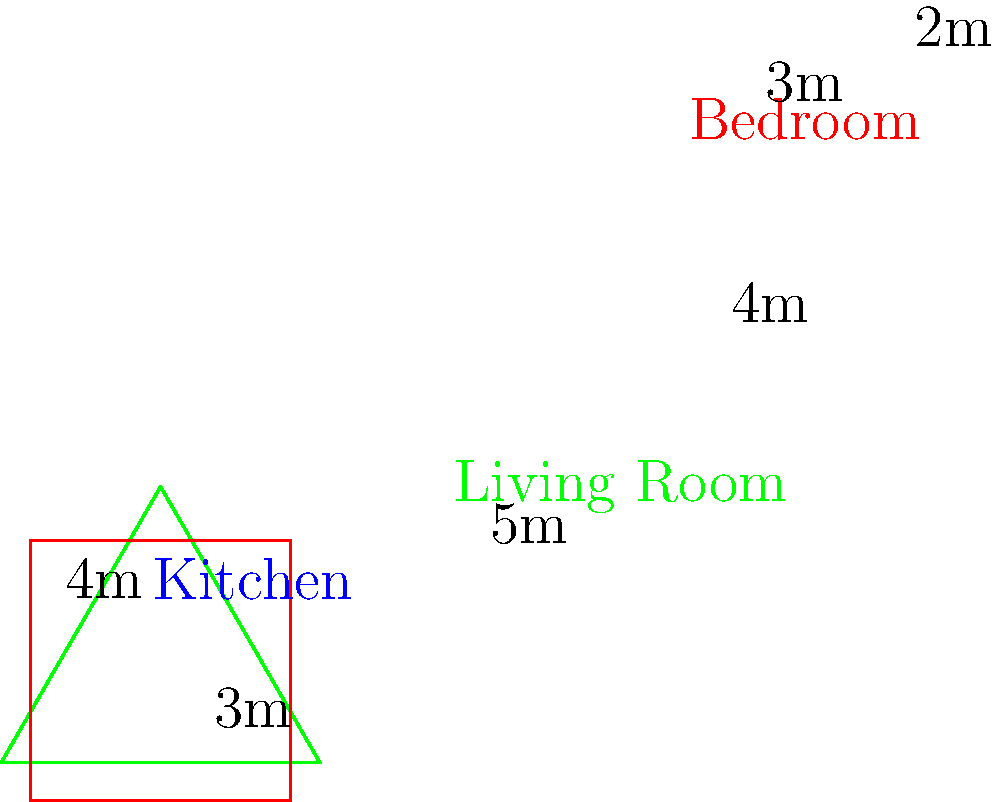In your compact city apartment, you need to calculate the total floor space. The apartment consists of three rooms: a rectangular kitchen (3m x 4m), a triangular living room (base 5m, height 4m), and an L-shaped bedroom. The bedroom is composed of a 3m x 2m rectangle attached to a 1m x 2m rectangle. What is the total floor space of your apartment in square meters? Let's calculate the area of each room separately:

1. Kitchen (rectangle):
   Area = length × width
   $A_k = 3m \times 4m = 12m^2$

2. Living Room (triangle):
   Area = $\frac{1}{2} \times$ base × height
   $A_l = \frac{1}{2} \times 5m \times 4m = 10m^2$

3. Bedroom (L-shape, composed of two rectangles):
   Rectangle 1: $3m \times 2m = 6m^2$
   Rectangle 2: $1m \times 2m = 2m^2$
   Total bedroom area: $A_b = 6m^2 + 2m^2 = 8m^2$

Total floor space:
$A_{total} = A_k + A_l + A_b$
$A_{total} = 12m^2 + 10m^2 + 8m^2 = 30m^2$
Answer: $30m^2$ 